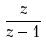<formula> <loc_0><loc_0><loc_500><loc_500>\frac { z } { z - 1 }</formula> 